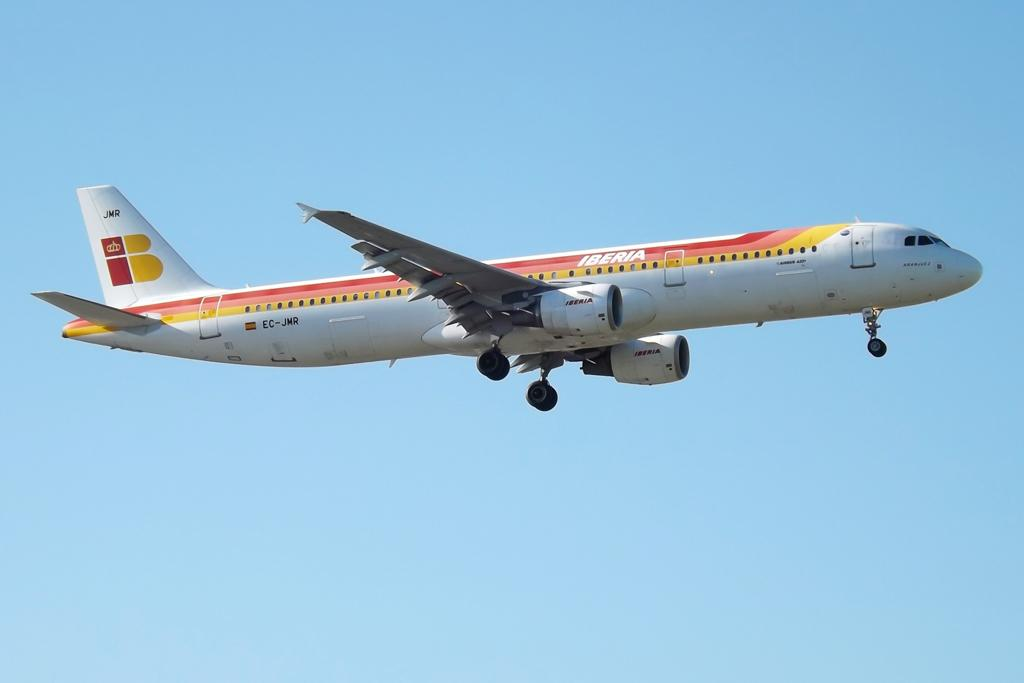<image>
Summarize the visual content of the image. An Iberia airplane is flying in the blue sky. 